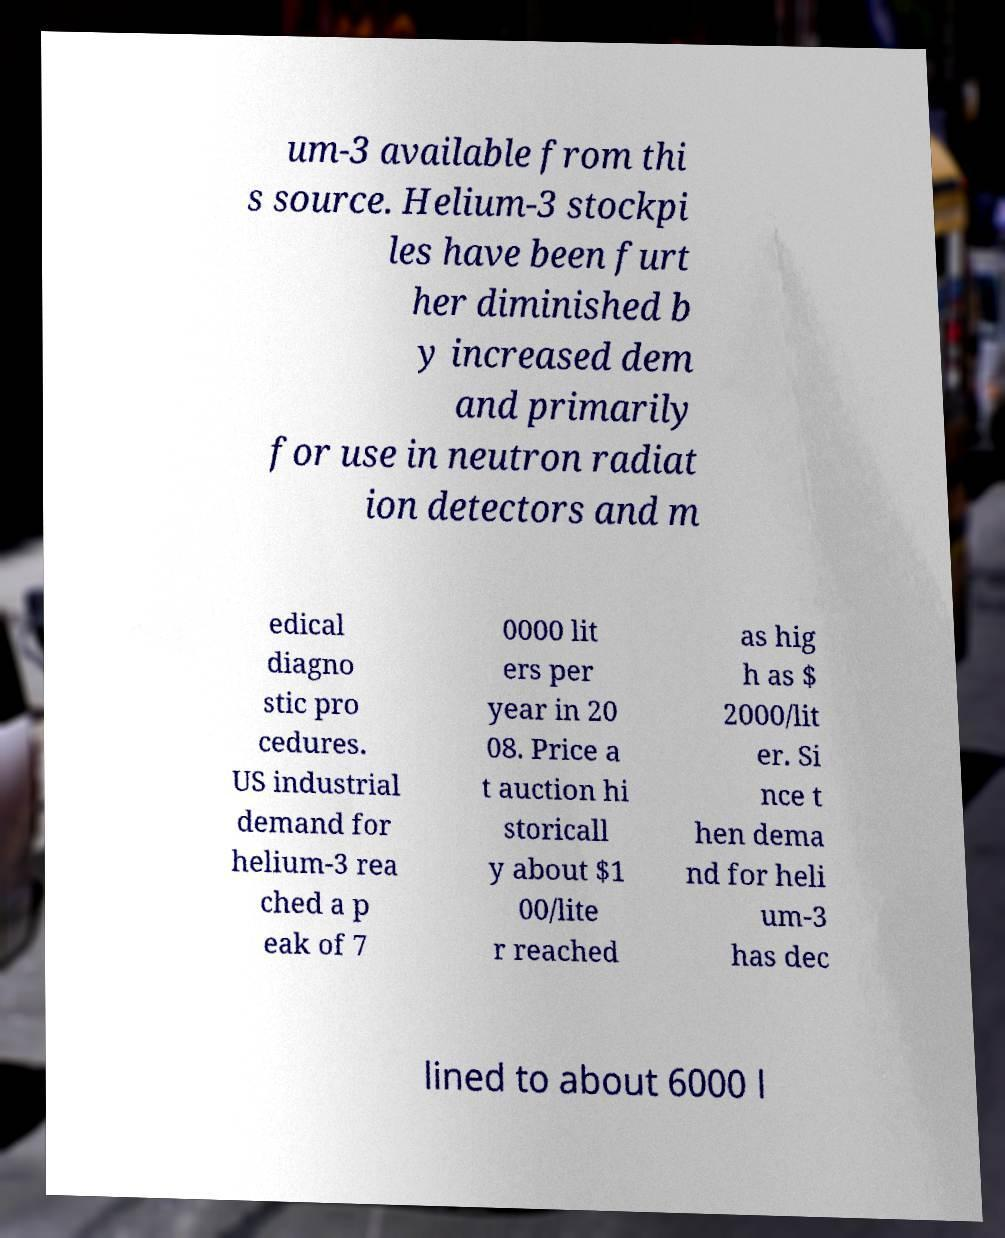For documentation purposes, I need the text within this image transcribed. Could you provide that? um-3 available from thi s source. Helium-3 stockpi les have been furt her diminished b y increased dem and primarily for use in neutron radiat ion detectors and m edical diagno stic pro cedures. US industrial demand for helium-3 rea ched a p eak of 7 0000 lit ers per year in 20 08. Price a t auction hi storicall y about $1 00/lite r reached as hig h as $ 2000/lit er. Si nce t hen dema nd for heli um-3 has dec lined to about 6000 l 